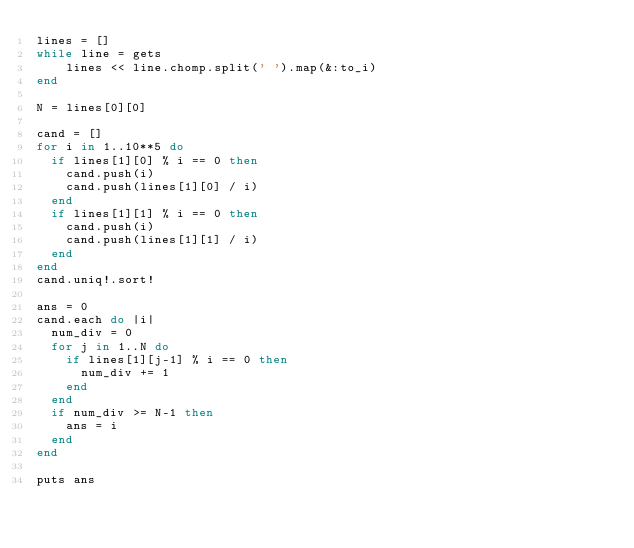<code> <loc_0><loc_0><loc_500><loc_500><_Ruby_>lines = []
while line = gets
    lines << line.chomp.split(' ').map(&:to_i)
end

N = lines[0][0]

cand = []
for i in 1..10**5 do
  if lines[1][0] % i == 0 then
    cand.push(i)
    cand.push(lines[1][0] / i)
  end
  if lines[1][1] % i == 0 then
    cand.push(i)
    cand.push(lines[1][1] / i)
  end
end
cand.uniq!.sort!

ans = 0
cand.each do |i|
  num_div = 0
  for j in 1..N do
    if lines[1][j-1] % i == 0 then
      num_div += 1
    end
  end
  if num_div >= N-1 then
    ans = i
  end
end
    
puts ans</code> 